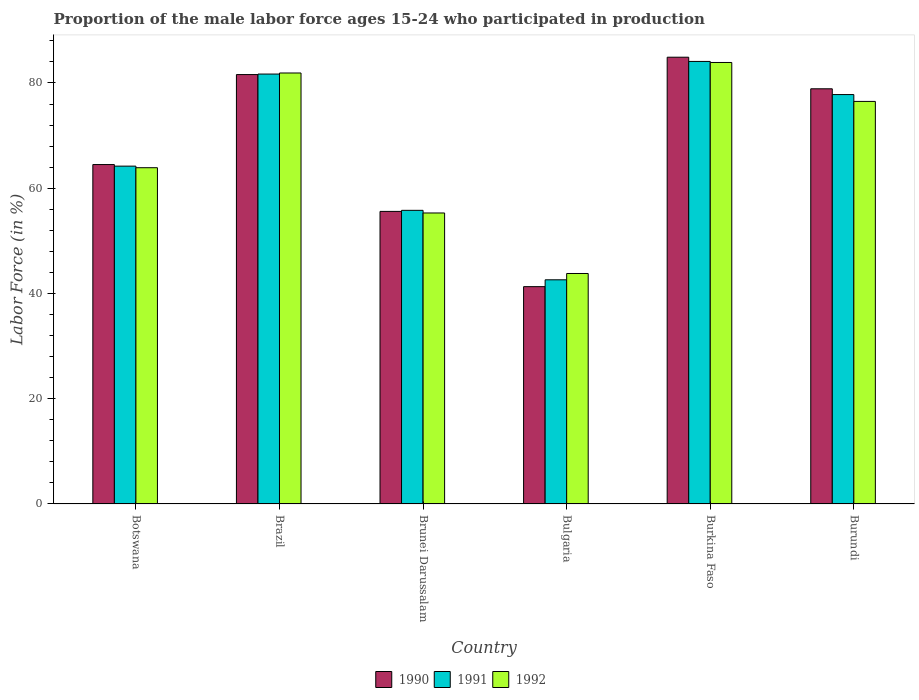Are the number of bars on each tick of the X-axis equal?
Your response must be concise. Yes. How many bars are there on the 4th tick from the right?
Offer a very short reply. 3. What is the label of the 2nd group of bars from the left?
Make the answer very short. Brazil. In how many cases, is the number of bars for a given country not equal to the number of legend labels?
Make the answer very short. 0. What is the proportion of the male labor force who participated in production in 1992 in Botswana?
Give a very brief answer. 63.9. Across all countries, what is the maximum proportion of the male labor force who participated in production in 1991?
Give a very brief answer. 84.1. Across all countries, what is the minimum proportion of the male labor force who participated in production in 1990?
Offer a terse response. 41.3. In which country was the proportion of the male labor force who participated in production in 1991 maximum?
Keep it short and to the point. Burkina Faso. In which country was the proportion of the male labor force who participated in production in 1992 minimum?
Give a very brief answer. Bulgaria. What is the total proportion of the male labor force who participated in production in 1990 in the graph?
Offer a terse response. 406.8. What is the difference between the proportion of the male labor force who participated in production in 1990 in Brunei Darussalam and that in Bulgaria?
Offer a terse response. 14.3. What is the difference between the proportion of the male labor force who participated in production in 1992 in Botswana and the proportion of the male labor force who participated in production in 1991 in Brunei Darussalam?
Offer a terse response. 8.1. What is the average proportion of the male labor force who participated in production in 1992 per country?
Provide a short and direct response. 67.55. What is the difference between the proportion of the male labor force who participated in production of/in 1991 and proportion of the male labor force who participated in production of/in 1990 in Burkina Faso?
Your answer should be compact. -0.8. In how many countries, is the proportion of the male labor force who participated in production in 1990 greater than 4 %?
Make the answer very short. 6. What is the ratio of the proportion of the male labor force who participated in production in 1991 in Botswana to that in Brunei Darussalam?
Offer a terse response. 1.15. Is the difference between the proportion of the male labor force who participated in production in 1991 in Brunei Darussalam and Burundi greater than the difference between the proportion of the male labor force who participated in production in 1990 in Brunei Darussalam and Burundi?
Give a very brief answer. Yes. What is the difference between the highest and the second highest proportion of the male labor force who participated in production in 1992?
Keep it short and to the point. -2. What is the difference between the highest and the lowest proportion of the male labor force who participated in production in 1990?
Ensure brevity in your answer.  43.6. In how many countries, is the proportion of the male labor force who participated in production in 1990 greater than the average proportion of the male labor force who participated in production in 1990 taken over all countries?
Make the answer very short. 3. Is the sum of the proportion of the male labor force who participated in production in 1990 in Burkina Faso and Burundi greater than the maximum proportion of the male labor force who participated in production in 1992 across all countries?
Your response must be concise. Yes. What does the 3rd bar from the left in Brunei Darussalam represents?
Offer a terse response. 1992. What does the 3rd bar from the right in Bulgaria represents?
Make the answer very short. 1990. Are all the bars in the graph horizontal?
Provide a succinct answer. No. What is the difference between two consecutive major ticks on the Y-axis?
Give a very brief answer. 20. Are the values on the major ticks of Y-axis written in scientific E-notation?
Offer a very short reply. No. How are the legend labels stacked?
Your answer should be compact. Horizontal. What is the title of the graph?
Provide a short and direct response. Proportion of the male labor force ages 15-24 who participated in production. Does "1998" appear as one of the legend labels in the graph?
Provide a succinct answer. No. What is the label or title of the Y-axis?
Give a very brief answer. Labor Force (in %). What is the Labor Force (in %) in 1990 in Botswana?
Offer a terse response. 64.5. What is the Labor Force (in %) of 1991 in Botswana?
Ensure brevity in your answer.  64.2. What is the Labor Force (in %) in 1992 in Botswana?
Offer a very short reply. 63.9. What is the Labor Force (in %) of 1990 in Brazil?
Offer a very short reply. 81.6. What is the Labor Force (in %) in 1991 in Brazil?
Offer a very short reply. 81.7. What is the Labor Force (in %) of 1992 in Brazil?
Provide a succinct answer. 81.9. What is the Labor Force (in %) in 1990 in Brunei Darussalam?
Your answer should be very brief. 55.6. What is the Labor Force (in %) in 1991 in Brunei Darussalam?
Offer a terse response. 55.8. What is the Labor Force (in %) of 1992 in Brunei Darussalam?
Your response must be concise. 55.3. What is the Labor Force (in %) in 1990 in Bulgaria?
Ensure brevity in your answer.  41.3. What is the Labor Force (in %) in 1991 in Bulgaria?
Offer a terse response. 42.6. What is the Labor Force (in %) in 1992 in Bulgaria?
Offer a terse response. 43.8. What is the Labor Force (in %) of 1990 in Burkina Faso?
Offer a very short reply. 84.9. What is the Labor Force (in %) in 1991 in Burkina Faso?
Your response must be concise. 84.1. What is the Labor Force (in %) in 1992 in Burkina Faso?
Your answer should be compact. 83.9. What is the Labor Force (in %) of 1990 in Burundi?
Ensure brevity in your answer.  78.9. What is the Labor Force (in %) in 1991 in Burundi?
Give a very brief answer. 77.8. What is the Labor Force (in %) in 1992 in Burundi?
Give a very brief answer. 76.5. Across all countries, what is the maximum Labor Force (in %) in 1990?
Make the answer very short. 84.9. Across all countries, what is the maximum Labor Force (in %) of 1991?
Your response must be concise. 84.1. Across all countries, what is the maximum Labor Force (in %) in 1992?
Your answer should be compact. 83.9. Across all countries, what is the minimum Labor Force (in %) of 1990?
Your answer should be very brief. 41.3. Across all countries, what is the minimum Labor Force (in %) in 1991?
Provide a short and direct response. 42.6. Across all countries, what is the minimum Labor Force (in %) in 1992?
Ensure brevity in your answer.  43.8. What is the total Labor Force (in %) of 1990 in the graph?
Keep it short and to the point. 406.8. What is the total Labor Force (in %) in 1991 in the graph?
Your answer should be very brief. 406.2. What is the total Labor Force (in %) in 1992 in the graph?
Ensure brevity in your answer.  405.3. What is the difference between the Labor Force (in %) of 1990 in Botswana and that in Brazil?
Make the answer very short. -17.1. What is the difference between the Labor Force (in %) in 1991 in Botswana and that in Brazil?
Offer a very short reply. -17.5. What is the difference between the Labor Force (in %) in 1992 in Botswana and that in Brazil?
Keep it short and to the point. -18. What is the difference between the Labor Force (in %) of 1991 in Botswana and that in Brunei Darussalam?
Keep it short and to the point. 8.4. What is the difference between the Labor Force (in %) of 1992 in Botswana and that in Brunei Darussalam?
Provide a succinct answer. 8.6. What is the difference between the Labor Force (in %) in 1990 in Botswana and that in Bulgaria?
Your answer should be compact. 23.2. What is the difference between the Labor Force (in %) of 1991 in Botswana and that in Bulgaria?
Your answer should be compact. 21.6. What is the difference between the Labor Force (in %) in 1992 in Botswana and that in Bulgaria?
Provide a short and direct response. 20.1. What is the difference between the Labor Force (in %) in 1990 in Botswana and that in Burkina Faso?
Offer a very short reply. -20.4. What is the difference between the Labor Force (in %) in 1991 in Botswana and that in Burkina Faso?
Your response must be concise. -19.9. What is the difference between the Labor Force (in %) of 1992 in Botswana and that in Burkina Faso?
Provide a succinct answer. -20. What is the difference between the Labor Force (in %) of 1990 in Botswana and that in Burundi?
Offer a very short reply. -14.4. What is the difference between the Labor Force (in %) in 1990 in Brazil and that in Brunei Darussalam?
Your response must be concise. 26. What is the difference between the Labor Force (in %) of 1991 in Brazil and that in Brunei Darussalam?
Make the answer very short. 25.9. What is the difference between the Labor Force (in %) in 1992 in Brazil and that in Brunei Darussalam?
Your answer should be very brief. 26.6. What is the difference between the Labor Force (in %) of 1990 in Brazil and that in Bulgaria?
Provide a succinct answer. 40.3. What is the difference between the Labor Force (in %) of 1991 in Brazil and that in Bulgaria?
Make the answer very short. 39.1. What is the difference between the Labor Force (in %) of 1992 in Brazil and that in Bulgaria?
Keep it short and to the point. 38.1. What is the difference between the Labor Force (in %) of 1990 in Brazil and that in Burkina Faso?
Your response must be concise. -3.3. What is the difference between the Labor Force (in %) in 1991 in Brazil and that in Burkina Faso?
Offer a very short reply. -2.4. What is the difference between the Labor Force (in %) of 1992 in Brazil and that in Burkina Faso?
Offer a terse response. -2. What is the difference between the Labor Force (in %) of 1990 in Brazil and that in Burundi?
Make the answer very short. 2.7. What is the difference between the Labor Force (in %) of 1991 in Brazil and that in Burundi?
Your answer should be compact. 3.9. What is the difference between the Labor Force (in %) in 1991 in Brunei Darussalam and that in Bulgaria?
Your answer should be compact. 13.2. What is the difference between the Labor Force (in %) of 1992 in Brunei Darussalam and that in Bulgaria?
Ensure brevity in your answer.  11.5. What is the difference between the Labor Force (in %) in 1990 in Brunei Darussalam and that in Burkina Faso?
Your answer should be very brief. -29.3. What is the difference between the Labor Force (in %) of 1991 in Brunei Darussalam and that in Burkina Faso?
Provide a short and direct response. -28.3. What is the difference between the Labor Force (in %) in 1992 in Brunei Darussalam and that in Burkina Faso?
Provide a short and direct response. -28.6. What is the difference between the Labor Force (in %) of 1990 in Brunei Darussalam and that in Burundi?
Ensure brevity in your answer.  -23.3. What is the difference between the Labor Force (in %) of 1992 in Brunei Darussalam and that in Burundi?
Offer a terse response. -21.2. What is the difference between the Labor Force (in %) of 1990 in Bulgaria and that in Burkina Faso?
Your answer should be very brief. -43.6. What is the difference between the Labor Force (in %) of 1991 in Bulgaria and that in Burkina Faso?
Offer a terse response. -41.5. What is the difference between the Labor Force (in %) in 1992 in Bulgaria and that in Burkina Faso?
Keep it short and to the point. -40.1. What is the difference between the Labor Force (in %) in 1990 in Bulgaria and that in Burundi?
Make the answer very short. -37.6. What is the difference between the Labor Force (in %) of 1991 in Bulgaria and that in Burundi?
Offer a very short reply. -35.2. What is the difference between the Labor Force (in %) in 1992 in Bulgaria and that in Burundi?
Ensure brevity in your answer.  -32.7. What is the difference between the Labor Force (in %) of 1990 in Burkina Faso and that in Burundi?
Make the answer very short. 6. What is the difference between the Labor Force (in %) of 1991 in Burkina Faso and that in Burundi?
Keep it short and to the point. 6.3. What is the difference between the Labor Force (in %) in 1992 in Burkina Faso and that in Burundi?
Ensure brevity in your answer.  7.4. What is the difference between the Labor Force (in %) in 1990 in Botswana and the Labor Force (in %) in 1991 in Brazil?
Provide a short and direct response. -17.2. What is the difference between the Labor Force (in %) of 1990 in Botswana and the Labor Force (in %) of 1992 in Brazil?
Provide a short and direct response. -17.4. What is the difference between the Labor Force (in %) of 1991 in Botswana and the Labor Force (in %) of 1992 in Brazil?
Your answer should be compact. -17.7. What is the difference between the Labor Force (in %) of 1990 in Botswana and the Labor Force (in %) of 1992 in Brunei Darussalam?
Your answer should be very brief. 9.2. What is the difference between the Labor Force (in %) of 1990 in Botswana and the Labor Force (in %) of 1991 in Bulgaria?
Give a very brief answer. 21.9. What is the difference between the Labor Force (in %) in 1990 in Botswana and the Labor Force (in %) in 1992 in Bulgaria?
Your response must be concise. 20.7. What is the difference between the Labor Force (in %) of 1991 in Botswana and the Labor Force (in %) of 1992 in Bulgaria?
Your response must be concise. 20.4. What is the difference between the Labor Force (in %) of 1990 in Botswana and the Labor Force (in %) of 1991 in Burkina Faso?
Offer a very short reply. -19.6. What is the difference between the Labor Force (in %) of 1990 in Botswana and the Labor Force (in %) of 1992 in Burkina Faso?
Give a very brief answer. -19.4. What is the difference between the Labor Force (in %) of 1991 in Botswana and the Labor Force (in %) of 1992 in Burkina Faso?
Provide a short and direct response. -19.7. What is the difference between the Labor Force (in %) of 1990 in Botswana and the Labor Force (in %) of 1991 in Burundi?
Ensure brevity in your answer.  -13.3. What is the difference between the Labor Force (in %) in 1990 in Botswana and the Labor Force (in %) in 1992 in Burundi?
Your answer should be very brief. -12. What is the difference between the Labor Force (in %) in 1990 in Brazil and the Labor Force (in %) in 1991 in Brunei Darussalam?
Your answer should be very brief. 25.8. What is the difference between the Labor Force (in %) in 1990 in Brazil and the Labor Force (in %) in 1992 in Brunei Darussalam?
Give a very brief answer. 26.3. What is the difference between the Labor Force (in %) in 1991 in Brazil and the Labor Force (in %) in 1992 in Brunei Darussalam?
Your answer should be very brief. 26.4. What is the difference between the Labor Force (in %) in 1990 in Brazil and the Labor Force (in %) in 1991 in Bulgaria?
Offer a very short reply. 39. What is the difference between the Labor Force (in %) in 1990 in Brazil and the Labor Force (in %) in 1992 in Bulgaria?
Offer a very short reply. 37.8. What is the difference between the Labor Force (in %) in 1991 in Brazil and the Labor Force (in %) in 1992 in Bulgaria?
Your response must be concise. 37.9. What is the difference between the Labor Force (in %) in 1990 in Brazil and the Labor Force (in %) in 1991 in Burkina Faso?
Offer a terse response. -2.5. What is the difference between the Labor Force (in %) of 1991 in Brazil and the Labor Force (in %) of 1992 in Burundi?
Offer a very short reply. 5.2. What is the difference between the Labor Force (in %) of 1990 in Brunei Darussalam and the Labor Force (in %) of 1991 in Bulgaria?
Offer a terse response. 13. What is the difference between the Labor Force (in %) in 1991 in Brunei Darussalam and the Labor Force (in %) in 1992 in Bulgaria?
Your answer should be compact. 12. What is the difference between the Labor Force (in %) in 1990 in Brunei Darussalam and the Labor Force (in %) in 1991 in Burkina Faso?
Provide a short and direct response. -28.5. What is the difference between the Labor Force (in %) of 1990 in Brunei Darussalam and the Labor Force (in %) of 1992 in Burkina Faso?
Offer a very short reply. -28.3. What is the difference between the Labor Force (in %) in 1991 in Brunei Darussalam and the Labor Force (in %) in 1992 in Burkina Faso?
Provide a succinct answer. -28.1. What is the difference between the Labor Force (in %) in 1990 in Brunei Darussalam and the Labor Force (in %) in 1991 in Burundi?
Your answer should be compact. -22.2. What is the difference between the Labor Force (in %) in 1990 in Brunei Darussalam and the Labor Force (in %) in 1992 in Burundi?
Offer a very short reply. -20.9. What is the difference between the Labor Force (in %) of 1991 in Brunei Darussalam and the Labor Force (in %) of 1992 in Burundi?
Keep it short and to the point. -20.7. What is the difference between the Labor Force (in %) of 1990 in Bulgaria and the Labor Force (in %) of 1991 in Burkina Faso?
Keep it short and to the point. -42.8. What is the difference between the Labor Force (in %) of 1990 in Bulgaria and the Labor Force (in %) of 1992 in Burkina Faso?
Provide a succinct answer. -42.6. What is the difference between the Labor Force (in %) of 1991 in Bulgaria and the Labor Force (in %) of 1992 in Burkina Faso?
Provide a succinct answer. -41.3. What is the difference between the Labor Force (in %) in 1990 in Bulgaria and the Labor Force (in %) in 1991 in Burundi?
Provide a succinct answer. -36.5. What is the difference between the Labor Force (in %) of 1990 in Bulgaria and the Labor Force (in %) of 1992 in Burundi?
Keep it short and to the point. -35.2. What is the difference between the Labor Force (in %) of 1991 in Bulgaria and the Labor Force (in %) of 1992 in Burundi?
Offer a very short reply. -33.9. What is the difference between the Labor Force (in %) in 1991 in Burkina Faso and the Labor Force (in %) in 1992 in Burundi?
Ensure brevity in your answer.  7.6. What is the average Labor Force (in %) in 1990 per country?
Make the answer very short. 67.8. What is the average Labor Force (in %) in 1991 per country?
Offer a terse response. 67.7. What is the average Labor Force (in %) of 1992 per country?
Offer a terse response. 67.55. What is the difference between the Labor Force (in %) of 1990 and Labor Force (in %) of 1992 in Botswana?
Give a very brief answer. 0.6. What is the difference between the Labor Force (in %) of 1990 and Labor Force (in %) of 1992 in Brazil?
Provide a succinct answer. -0.3. What is the difference between the Labor Force (in %) in 1991 and Labor Force (in %) in 1992 in Brazil?
Ensure brevity in your answer.  -0.2. What is the difference between the Labor Force (in %) of 1990 and Labor Force (in %) of 1992 in Bulgaria?
Provide a short and direct response. -2.5. What is the difference between the Labor Force (in %) in 1990 and Labor Force (in %) in 1992 in Burkina Faso?
Give a very brief answer. 1. What is the difference between the Labor Force (in %) of 1990 and Labor Force (in %) of 1991 in Burundi?
Provide a short and direct response. 1.1. What is the difference between the Labor Force (in %) in 1990 and Labor Force (in %) in 1992 in Burundi?
Keep it short and to the point. 2.4. What is the difference between the Labor Force (in %) in 1991 and Labor Force (in %) in 1992 in Burundi?
Offer a terse response. 1.3. What is the ratio of the Labor Force (in %) in 1990 in Botswana to that in Brazil?
Ensure brevity in your answer.  0.79. What is the ratio of the Labor Force (in %) of 1991 in Botswana to that in Brazil?
Your response must be concise. 0.79. What is the ratio of the Labor Force (in %) of 1992 in Botswana to that in Brazil?
Make the answer very short. 0.78. What is the ratio of the Labor Force (in %) of 1990 in Botswana to that in Brunei Darussalam?
Your answer should be very brief. 1.16. What is the ratio of the Labor Force (in %) in 1991 in Botswana to that in Brunei Darussalam?
Your answer should be very brief. 1.15. What is the ratio of the Labor Force (in %) of 1992 in Botswana to that in Brunei Darussalam?
Offer a very short reply. 1.16. What is the ratio of the Labor Force (in %) in 1990 in Botswana to that in Bulgaria?
Make the answer very short. 1.56. What is the ratio of the Labor Force (in %) in 1991 in Botswana to that in Bulgaria?
Provide a short and direct response. 1.51. What is the ratio of the Labor Force (in %) in 1992 in Botswana to that in Bulgaria?
Give a very brief answer. 1.46. What is the ratio of the Labor Force (in %) of 1990 in Botswana to that in Burkina Faso?
Offer a very short reply. 0.76. What is the ratio of the Labor Force (in %) of 1991 in Botswana to that in Burkina Faso?
Your response must be concise. 0.76. What is the ratio of the Labor Force (in %) in 1992 in Botswana to that in Burkina Faso?
Give a very brief answer. 0.76. What is the ratio of the Labor Force (in %) of 1990 in Botswana to that in Burundi?
Your answer should be compact. 0.82. What is the ratio of the Labor Force (in %) in 1991 in Botswana to that in Burundi?
Offer a terse response. 0.83. What is the ratio of the Labor Force (in %) in 1992 in Botswana to that in Burundi?
Offer a terse response. 0.84. What is the ratio of the Labor Force (in %) in 1990 in Brazil to that in Brunei Darussalam?
Your response must be concise. 1.47. What is the ratio of the Labor Force (in %) of 1991 in Brazil to that in Brunei Darussalam?
Your response must be concise. 1.46. What is the ratio of the Labor Force (in %) in 1992 in Brazil to that in Brunei Darussalam?
Your response must be concise. 1.48. What is the ratio of the Labor Force (in %) in 1990 in Brazil to that in Bulgaria?
Offer a very short reply. 1.98. What is the ratio of the Labor Force (in %) of 1991 in Brazil to that in Bulgaria?
Keep it short and to the point. 1.92. What is the ratio of the Labor Force (in %) in 1992 in Brazil to that in Bulgaria?
Your answer should be compact. 1.87. What is the ratio of the Labor Force (in %) of 1990 in Brazil to that in Burkina Faso?
Offer a terse response. 0.96. What is the ratio of the Labor Force (in %) in 1991 in Brazil to that in Burkina Faso?
Keep it short and to the point. 0.97. What is the ratio of the Labor Force (in %) of 1992 in Brazil to that in Burkina Faso?
Give a very brief answer. 0.98. What is the ratio of the Labor Force (in %) in 1990 in Brazil to that in Burundi?
Your answer should be very brief. 1.03. What is the ratio of the Labor Force (in %) in 1991 in Brazil to that in Burundi?
Keep it short and to the point. 1.05. What is the ratio of the Labor Force (in %) of 1992 in Brazil to that in Burundi?
Provide a short and direct response. 1.07. What is the ratio of the Labor Force (in %) of 1990 in Brunei Darussalam to that in Bulgaria?
Ensure brevity in your answer.  1.35. What is the ratio of the Labor Force (in %) of 1991 in Brunei Darussalam to that in Bulgaria?
Ensure brevity in your answer.  1.31. What is the ratio of the Labor Force (in %) of 1992 in Brunei Darussalam to that in Bulgaria?
Your response must be concise. 1.26. What is the ratio of the Labor Force (in %) in 1990 in Brunei Darussalam to that in Burkina Faso?
Provide a succinct answer. 0.65. What is the ratio of the Labor Force (in %) in 1991 in Brunei Darussalam to that in Burkina Faso?
Ensure brevity in your answer.  0.66. What is the ratio of the Labor Force (in %) of 1992 in Brunei Darussalam to that in Burkina Faso?
Provide a short and direct response. 0.66. What is the ratio of the Labor Force (in %) of 1990 in Brunei Darussalam to that in Burundi?
Your response must be concise. 0.7. What is the ratio of the Labor Force (in %) in 1991 in Brunei Darussalam to that in Burundi?
Your answer should be very brief. 0.72. What is the ratio of the Labor Force (in %) in 1992 in Brunei Darussalam to that in Burundi?
Offer a terse response. 0.72. What is the ratio of the Labor Force (in %) in 1990 in Bulgaria to that in Burkina Faso?
Offer a very short reply. 0.49. What is the ratio of the Labor Force (in %) of 1991 in Bulgaria to that in Burkina Faso?
Ensure brevity in your answer.  0.51. What is the ratio of the Labor Force (in %) of 1992 in Bulgaria to that in Burkina Faso?
Offer a terse response. 0.52. What is the ratio of the Labor Force (in %) in 1990 in Bulgaria to that in Burundi?
Make the answer very short. 0.52. What is the ratio of the Labor Force (in %) of 1991 in Bulgaria to that in Burundi?
Keep it short and to the point. 0.55. What is the ratio of the Labor Force (in %) in 1992 in Bulgaria to that in Burundi?
Provide a succinct answer. 0.57. What is the ratio of the Labor Force (in %) of 1990 in Burkina Faso to that in Burundi?
Offer a terse response. 1.08. What is the ratio of the Labor Force (in %) of 1991 in Burkina Faso to that in Burundi?
Provide a succinct answer. 1.08. What is the ratio of the Labor Force (in %) in 1992 in Burkina Faso to that in Burundi?
Your answer should be very brief. 1.1. What is the difference between the highest and the second highest Labor Force (in %) of 1990?
Your answer should be very brief. 3.3. What is the difference between the highest and the second highest Labor Force (in %) in 1991?
Provide a succinct answer. 2.4. What is the difference between the highest and the second highest Labor Force (in %) in 1992?
Give a very brief answer. 2. What is the difference between the highest and the lowest Labor Force (in %) in 1990?
Make the answer very short. 43.6. What is the difference between the highest and the lowest Labor Force (in %) of 1991?
Your answer should be very brief. 41.5. What is the difference between the highest and the lowest Labor Force (in %) in 1992?
Keep it short and to the point. 40.1. 